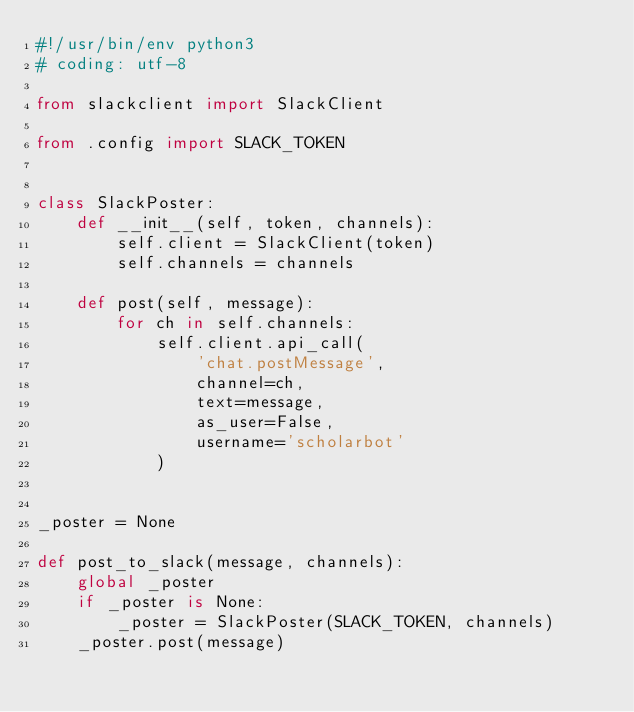Convert code to text. <code><loc_0><loc_0><loc_500><loc_500><_Python_>#!/usr/bin/env python3
# coding: utf-8

from slackclient import SlackClient

from .config import SLACK_TOKEN


class SlackPoster:
    def __init__(self, token, channels):
        self.client = SlackClient(token)
        self.channels = channels

    def post(self, message):
        for ch in self.channels:
            self.client.api_call(
                'chat.postMessage',
                channel=ch,
                text=message,
                as_user=False,
                username='scholarbot'
            )


_poster = None

def post_to_slack(message, channels):
    global _poster
    if _poster is None:
        _poster = SlackPoster(SLACK_TOKEN, channels)
    _poster.post(message)
</code> 